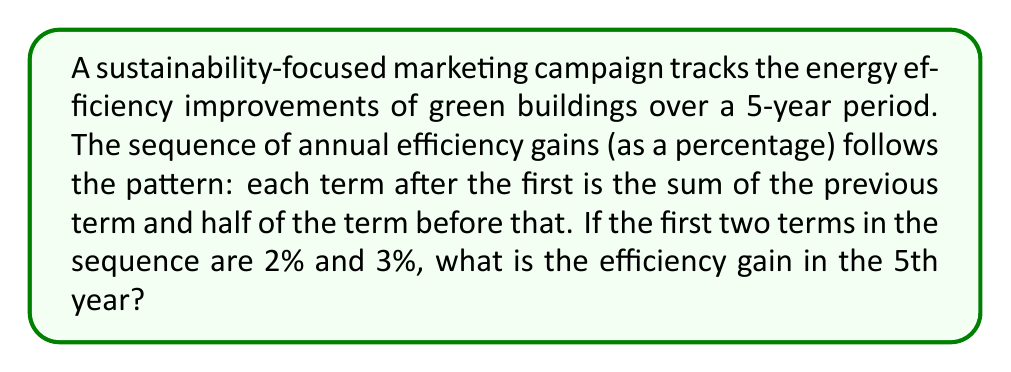Could you help me with this problem? Let's approach this step-by-step:

1) We're given that the first two terms of the sequence are:
   $a_1 = 2\%$ and $a_2 = 3\%$

2) The general formula for subsequent terms is:
   $a_n = a_{n-1} + \frac{1}{2}a_{n-2}$ for $n \geq 3$

3) Let's calculate the next terms:

   For $n = 3$:
   $a_3 = a_2 + \frac{1}{2}a_1 = 3 + \frac{1}{2}(2) = 3 + 1 = 4\%$

   For $n = 4$:
   $a_4 = a_3 + \frac{1}{2}a_2 = 4 + \frac{1}{2}(3) = 4 + 1.5 = 5.5\%$

   For $n = 5$ (our target):
   $a_5 = a_4 + \frac{1}{2}a_3 = 5.5 + \frac{1}{2}(4) = 5.5 + 2 = 7.5\%$

4) Therefore, the efficiency gain in the 5th year is 7.5%.
Answer: 7.5% 